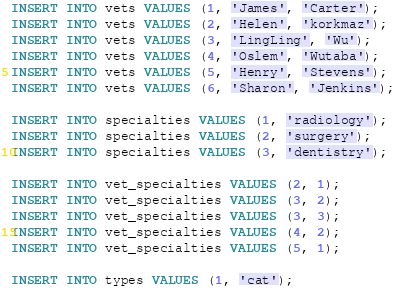Convert code to text. <code><loc_0><loc_0><loc_500><loc_500><_SQL_>INSERT INTO vets VALUES (1, 'James', 'Carter');
INSERT INTO vets VALUES (2, 'Helen', 'korkmaz');
INSERT INTO vets VALUES (3, 'LingLing', 'Wu');
INSERT INTO vets VALUES (4, 'Oslem', 'Wutaba');
INSERT INTO vets VALUES (5, 'Henry', 'Stevens');
INSERT INTO vets VALUES (6, 'Sharon', 'Jenkins');

INSERT INTO specialties VALUES (1, 'radiology');
INSERT INTO specialties VALUES (2, 'surgery');
INSERT INTO specialties VALUES (3, 'dentistry');

INSERT INTO vet_specialties VALUES (2, 1);
INSERT INTO vet_specialties VALUES (3, 2);
INSERT INTO vet_specialties VALUES (3, 3);
INSERT INTO vet_specialties VALUES (4, 2);
INSERT INTO vet_specialties VALUES (5, 1);

INSERT INTO types VALUES (1, 'cat');</code> 